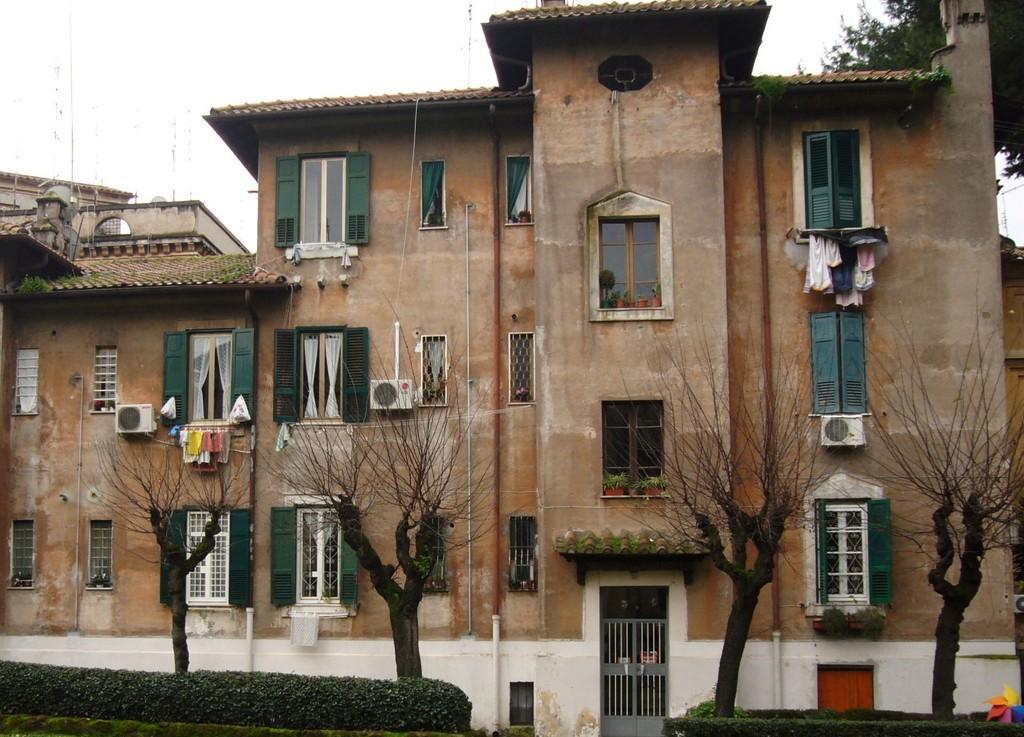In one or two sentences, can you explain what this image depicts? In the picture we can see a building with windows and glasses to it and under the building we can see a gate door, besides, we can see plants, and dried trees and behind the building we can see a sky. 